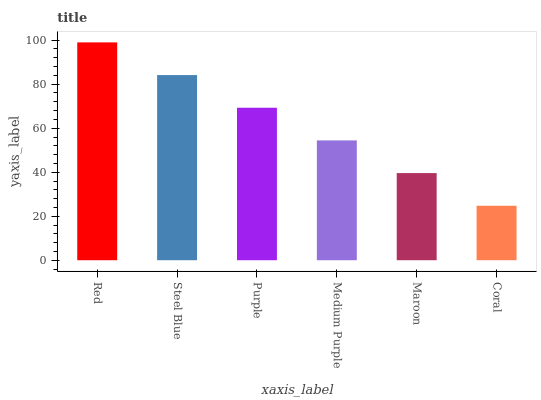Is Coral the minimum?
Answer yes or no. Yes. Is Red the maximum?
Answer yes or no. Yes. Is Steel Blue the minimum?
Answer yes or no. No. Is Steel Blue the maximum?
Answer yes or no. No. Is Red greater than Steel Blue?
Answer yes or no. Yes. Is Steel Blue less than Red?
Answer yes or no. Yes. Is Steel Blue greater than Red?
Answer yes or no. No. Is Red less than Steel Blue?
Answer yes or no. No. Is Purple the high median?
Answer yes or no. Yes. Is Medium Purple the low median?
Answer yes or no. Yes. Is Red the high median?
Answer yes or no. No. Is Steel Blue the low median?
Answer yes or no. No. 